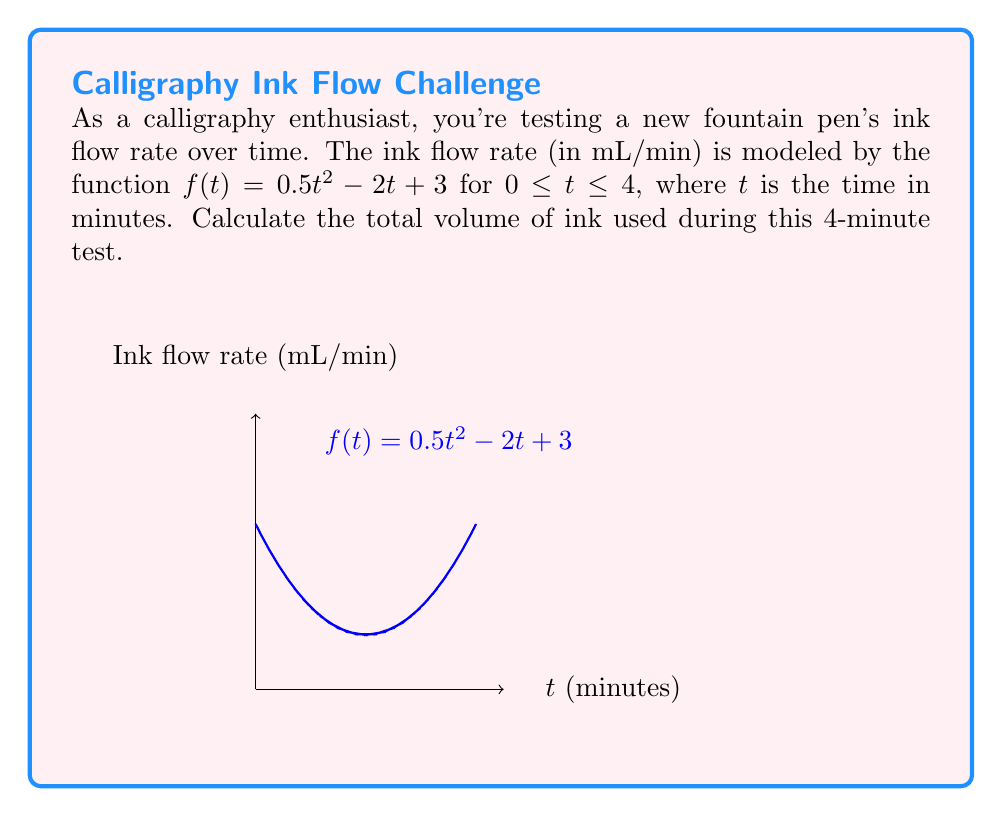What is the answer to this math problem? To find the total volume of ink used, we need to calculate the area under the curve of the ink flow rate function from $t=0$ to $t=4$. This can be done using definite integration.

1) The function representing ink flow rate is:
   $f(t) = 0.5t^2 - 2t + 3$

2) We need to integrate this function from 0 to 4:
   $\int_0^4 (0.5t^2 - 2t + 3) dt$

3) Integrate each term:
   $[\frac{1}{6}t^3 - t^2 + 3t]_0^4$

4) Evaluate the antiderivative at the upper and lower bounds:
   $(\frac{1}{6}(4^3) - 4^2 + 3(4)) - (\frac{1}{6}(0^3) - 0^2 + 3(0))$

5) Simplify:
   $(10.67 - 16 + 12) - (0 - 0 + 0) = 6.67$

Therefore, the total volume of ink used during the 4-minute test is 6.67 mL.
Answer: 6.67 mL 